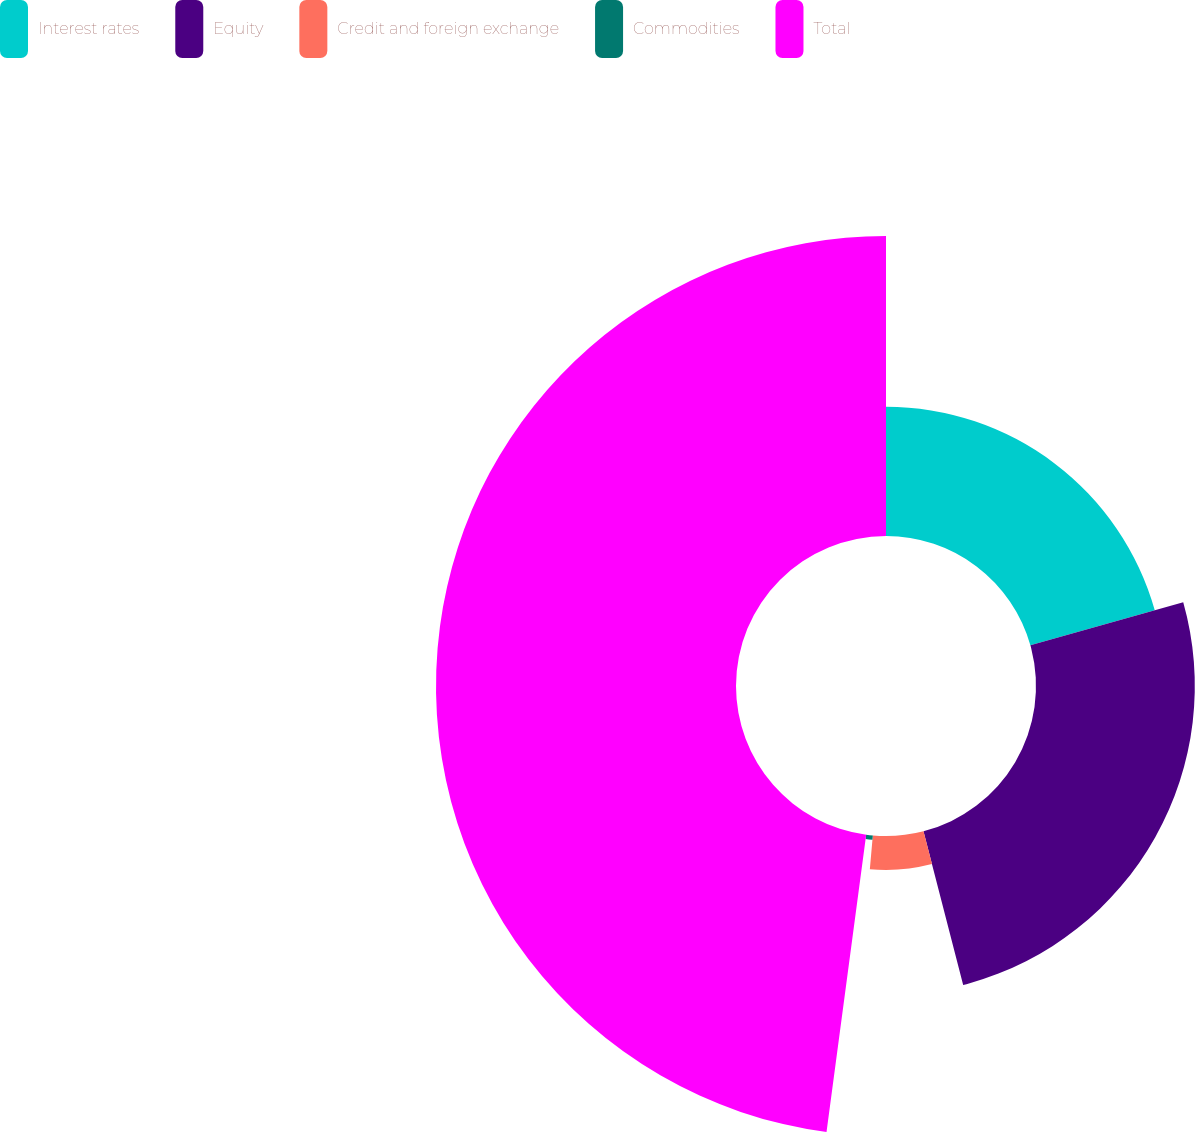<chart> <loc_0><loc_0><loc_500><loc_500><pie_chart><fcel>Interest rates<fcel>Equity<fcel>Credit and foreign exchange<fcel>Commodities<fcel>Total<nl><fcel>20.63%<fcel>25.35%<fcel>5.42%<fcel>0.71%<fcel>47.89%<nl></chart> 